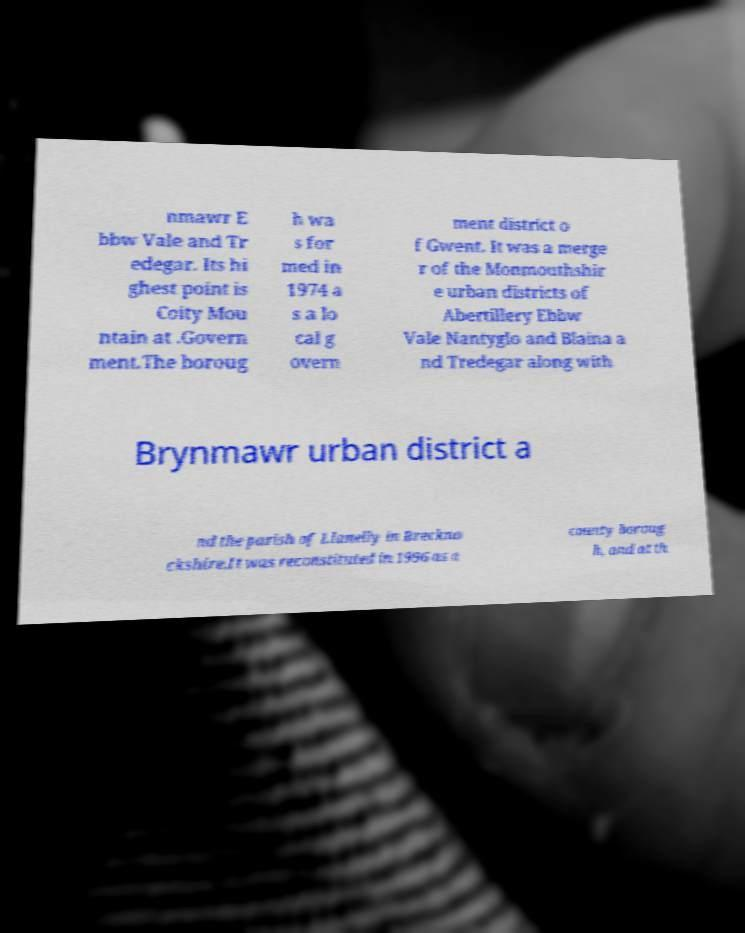For documentation purposes, I need the text within this image transcribed. Could you provide that? nmawr E bbw Vale and Tr edegar. Its hi ghest point is Coity Mou ntain at .Govern ment.The boroug h wa s for med in 1974 a s a lo cal g overn ment district o f Gwent. It was a merge r of the Monmouthshir e urban districts of Abertillery Ebbw Vale Nantyglo and Blaina a nd Tredegar along with Brynmawr urban district a nd the parish of Llanelly in Breckno ckshire.It was reconstituted in 1996 as a county boroug h, and at th 